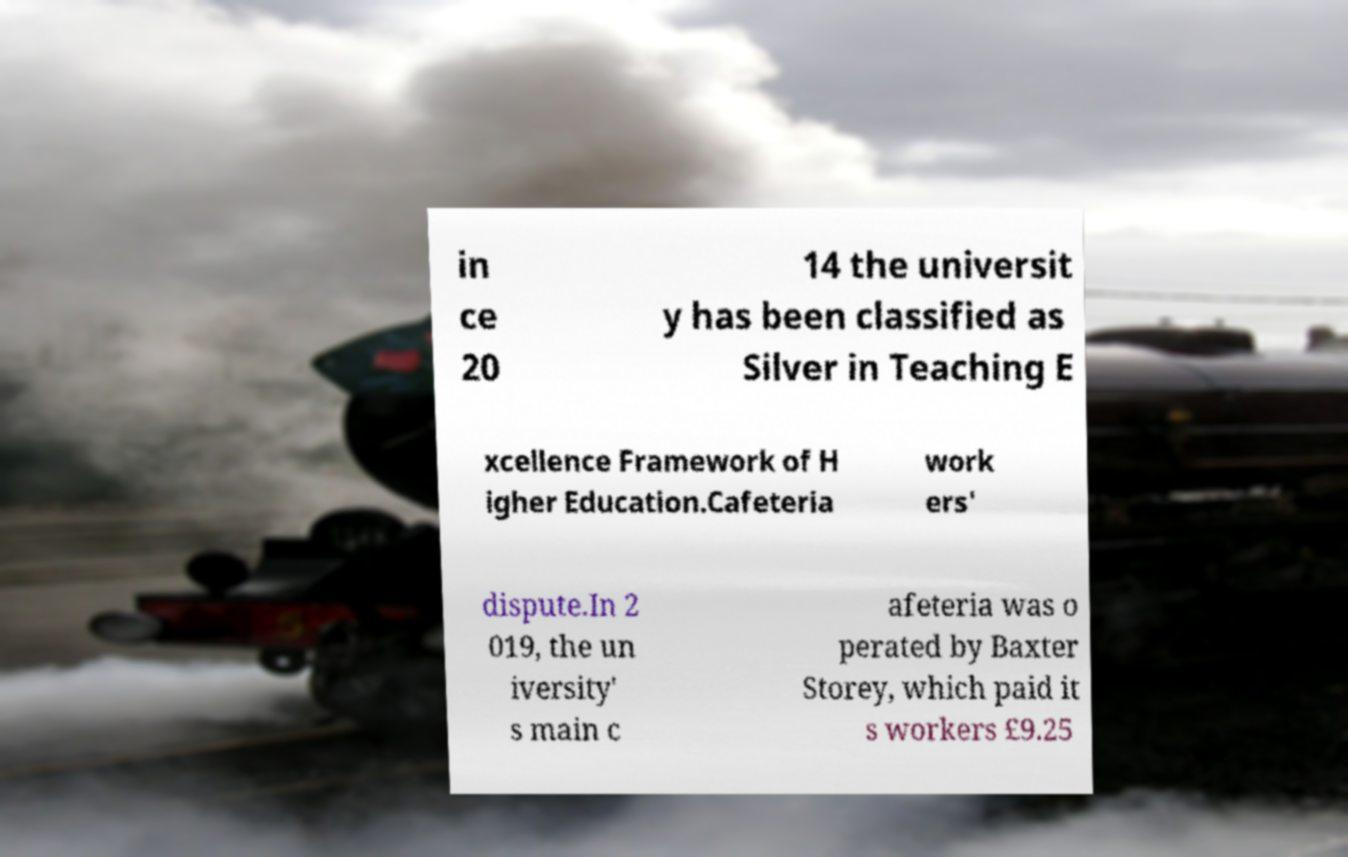Could you extract and type out the text from this image? in ce 20 14 the universit y has been classified as Silver in Teaching E xcellence Framework of H igher Education.Cafeteria work ers' dispute.In 2 019, the un iversity' s main c afeteria was o perated by Baxter Storey, which paid it s workers £9.25 